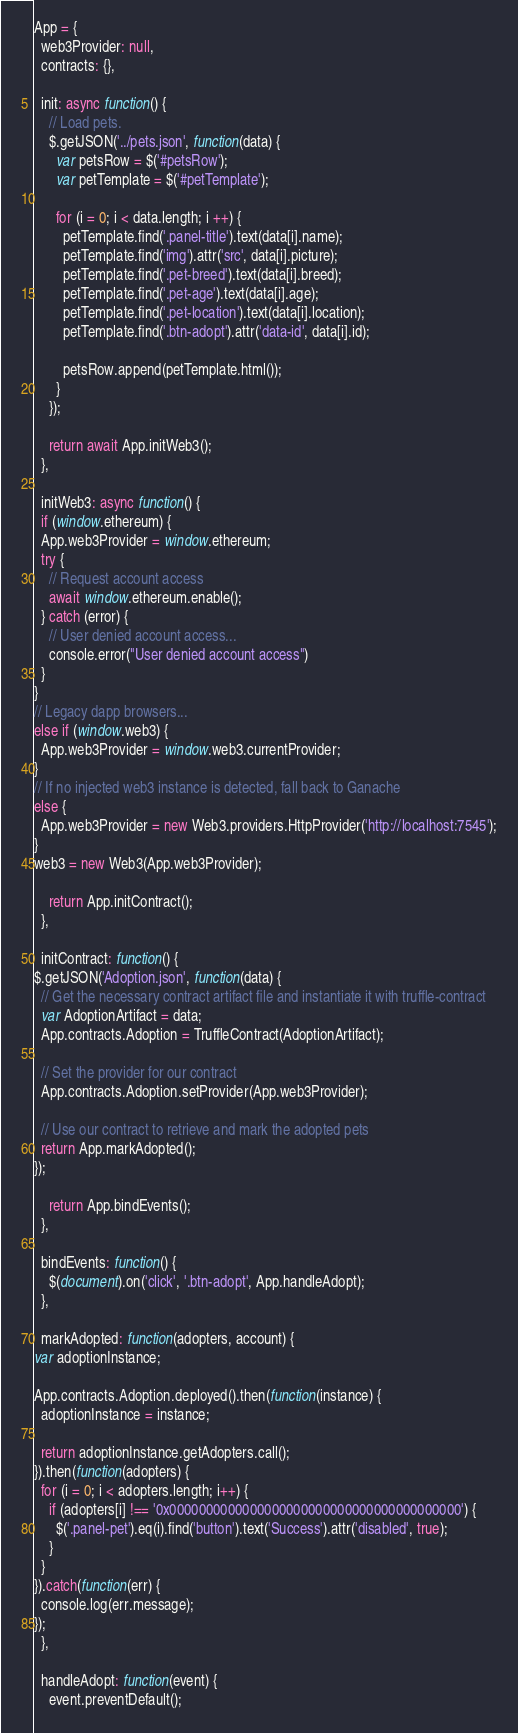<code> <loc_0><loc_0><loc_500><loc_500><_JavaScript_>App = {
  web3Provider: null,
  contracts: {},

  init: async function() {
    // Load pets.
    $.getJSON('../pets.json', function(data) {
      var petsRow = $('#petsRow');
      var petTemplate = $('#petTemplate');

      for (i = 0; i < data.length; i ++) {
        petTemplate.find('.panel-title').text(data[i].name);
        petTemplate.find('img').attr('src', data[i].picture);
        petTemplate.find('.pet-breed').text(data[i].breed);
        petTemplate.find('.pet-age').text(data[i].age);
        petTemplate.find('.pet-location').text(data[i].location);
        petTemplate.find('.btn-adopt').attr('data-id', data[i].id);

        petsRow.append(petTemplate.html());
      }
    });

    return await App.initWeb3();
  },

  initWeb3: async function() {
  if (window.ethereum) {
  App.web3Provider = window.ethereum;
  try {
    // Request account access
    await window.ethereum.enable();
  } catch (error) {
    // User denied account access...
    console.error("User denied account access")
  }
}
// Legacy dapp browsers...
else if (window.web3) {
  App.web3Provider = window.web3.currentProvider;
}
// If no injected web3 instance is detected, fall back to Ganache
else {
  App.web3Provider = new Web3.providers.HttpProvider('http://localhost:7545');
}
web3 = new Web3(App.web3Provider);

    return App.initContract();
  },

  initContract: function() {
$.getJSON('Adoption.json', function(data) {
  // Get the necessary contract artifact file and instantiate it with truffle-contract
  var AdoptionArtifact = data;
  App.contracts.Adoption = TruffleContract(AdoptionArtifact);

  // Set the provider for our contract
  App.contracts.Adoption.setProvider(App.web3Provider);

  // Use our contract to retrieve and mark the adopted pets
  return App.markAdopted();
});

    return App.bindEvents();
  },

  bindEvents: function() {
    $(document).on('click', '.btn-adopt', App.handleAdopt);
  },

  markAdopted: function(adopters, account) {
var adoptionInstance;

App.contracts.Adoption.deployed().then(function(instance) {
  adoptionInstance = instance;

  return adoptionInstance.getAdopters.call();
}).then(function(adopters) {
  for (i = 0; i < adopters.length; i++) {
    if (adopters[i] !== '0x0000000000000000000000000000000000000000') {
      $('.panel-pet').eq(i).find('button').text('Success').attr('disabled', true);
    }
  }
}).catch(function(err) {
  console.log(err.message);
});
  },

  handleAdopt: function(event) {
    event.preventDefault();
</code> 